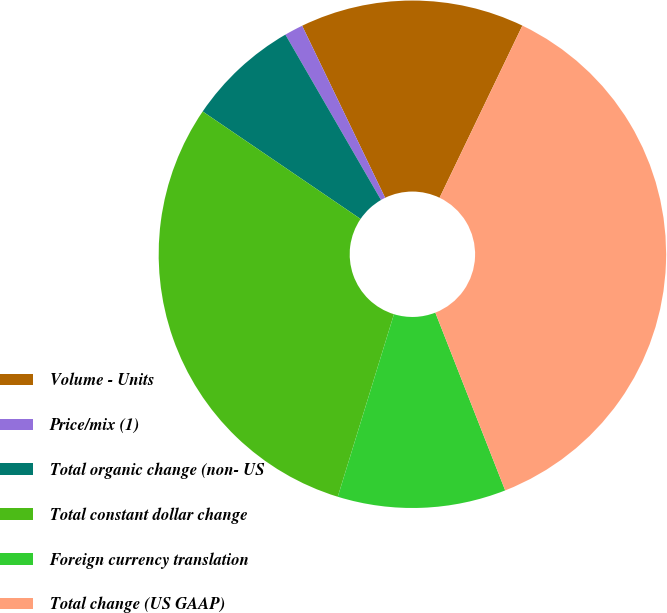Convert chart to OTSL. <chart><loc_0><loc_0><loc_500><loc_500><pie_chart><fcel>Volume - Units<fcel>Price/mix (1)<fcel>Total organic change (non- US<fcel>Total constant dollar change<fcel>Foreign currency translation<fcel>Total change (US GAAP)<nl><fcel>14.29%<fcel>1.19%<fcel>7.14%<fcel>29.76%<fcel>10.71%<fcel>36.9%<nl></chart> 